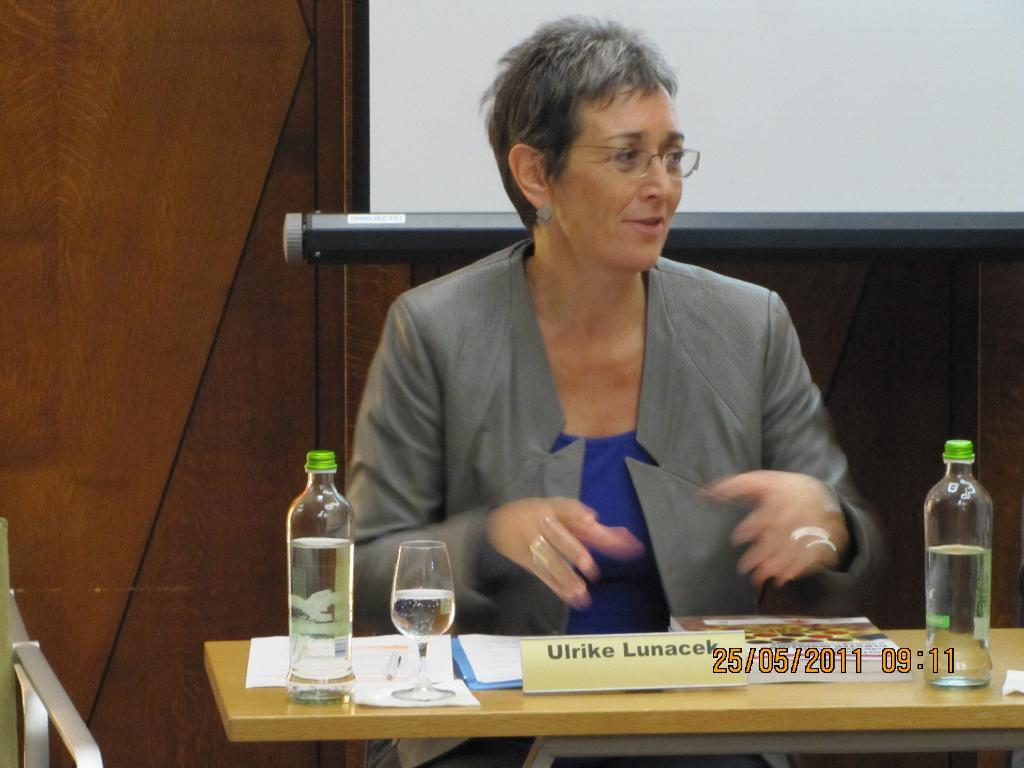<image>
Offer a succinct explanation of the picture presented. Ulrike Lunacek is shown at a podium or desk in a picture that is dated 25/05/2011. 